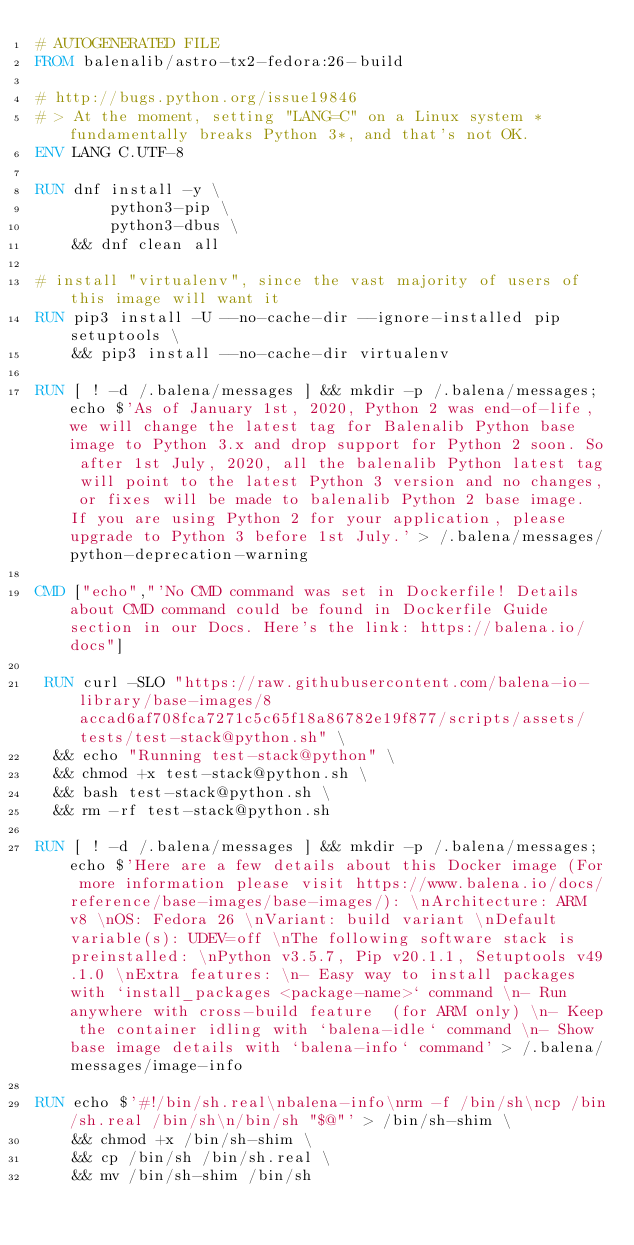Convert code to text. <code><loc_0><loc_0><loc_500><loc_500><_Dockerfile_># AUTOGENERATED FILE
FROM balenalib/astro-tx2-fedora:26-build

# http://bugs.python.org/issue19846
# > At the moment, setting "LANG=C" on a Linux system *fundamentally breaks Python 3*, and that's not OK.
ENV LANG C.UTF-8

RUN dnf install -y \
		python3-pip \
		python3-dbus \
	&& dnf clean all

# install "virtualenv", since the vast majority of users of this image will want it
RUN pip3 install -U --no-cache-dir --ignore-installed pip setuptools \
	&& pip3 install --no-cache-dir virtualenv

RUN [ ! -d /.balena/messages ] && mkdir -p /.balena/messages; echo $'As of January 1st, 2020, Python 2 was end-of-life, we will change the latest tag for Balenalib Python base image to Python 3.x and drop support for Python 2 soon. So after 1st July, 2020, all the balenalib Python latest tag will point to the latest Python 3 version and no changes, or fixes will be made to balenalib Python 2 base image. If you are using Python 2 for your application, please upgrade to Python 3 before 1st July.' > /.balena/messages/python-deprecation-warning

CMD ["echo","'No CMD command was set in Dockerfile! Details about CMD command could be found in Dockerfile Guide section in our Docs. Here's the link: https://balena.io/docs"]

 RUN curl -SLO "https://raw.githubusercontent.com/balena-io-library/base-images/8accad6af708fca7271c5c65f18a86782e19f877/scripts/assets/tests/test-stack@python.sh" \
  && echo "Running test-stack@python" \
  && chmod +x test-stack@python.sh \
  && bash test-stack@python.sh \
  && rm -rf test-stack@python.sh 

RUN [ ! -d /.balena/messages ] && mkdir -p /.balena/messages; echo $'Here are a few details about this Docker image (For more information please visit https://www.balena.io/docs/reference/base-images/base-images/): \nArchitecture: ARM v8 \nOS: Fedora 26 \nVariant: build variant \nDefault variable(s): UDEV=off \nThe following software stack is preinstalled: \nPython v3.5.7, Pip v20.1.1, Setuptools v49.1.0 \nExtra features: \n- Easy way to install packages with `install_packages <package-name>` command \n- Run anywhere with cross-build feature  (for ARM only) \n- Keep the container idling with `balena-idle` command \n- Show base image details with `balena-info` command' > /.balena/messages/image-info

RUN echo $'#!/bin/sh.real\nbalena-info\nrm -f /bin/sh\ncp /bin/sh.real /bin/sh\n/bin/sh "$@"' > /bin/sh-shim \
	&& chmod +x /bin/sh-shim \
	&& cp /bin/sh /bin/sh.real \
	&& mv /bin/sh-shim /bin/sh</code> 